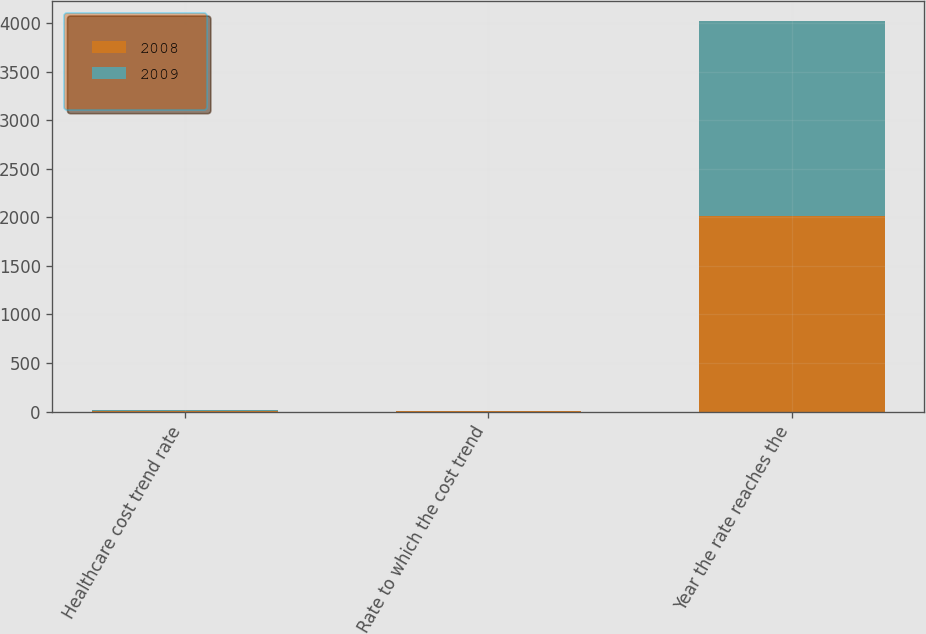<chart> <loc_0><loc_0><loc_500><loc_500><stacked_bar_chart><ecel><fcel>Healthcare cost trend rate<fcel>Rate to which the cost trend<fcel>Year the rate reaches the<nl><fcel>2008<fcel>9<fcel>5<fcel>2013<nl><fcel>2009<fcel>10<fcel>5<fcel>2013<nl></chart> 